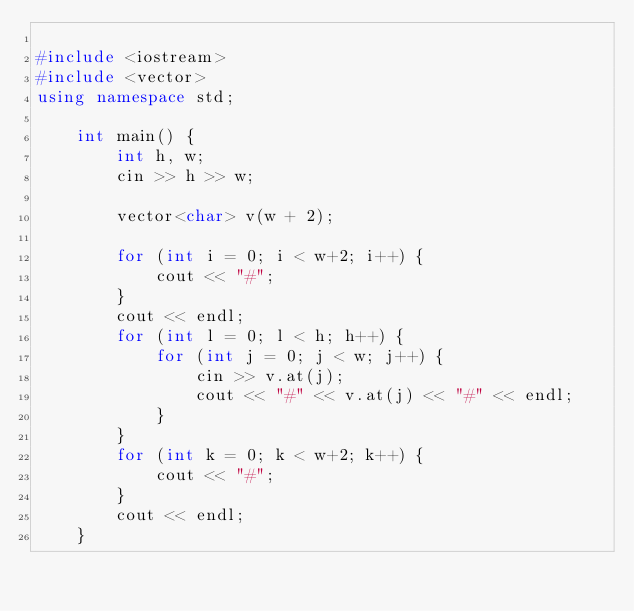<code> <loc_0><loc_0><loc_500><loc_500><_C++_>
#include <iostream>
#include <vector>
using namespace std;

	int main() {
		int h, w;
		cin >> h >> w;

		vector<char> v(w + 2);
		
		for (int i = 0; i < w+2; i++) {
			cout << "#";
		}
		cout << endl;
		for (int l = 0; l < h; h++) {
			for (int j = 0; j < w; j++) {
				cin >> v.at(j);
				cout << "#" << v.at(j) << "#" << endl;
			}
		}
		for (int k = 0; k < w+2; k++) {
			cout << "#";
		}
		cout << endl;
	}

  

</code> 